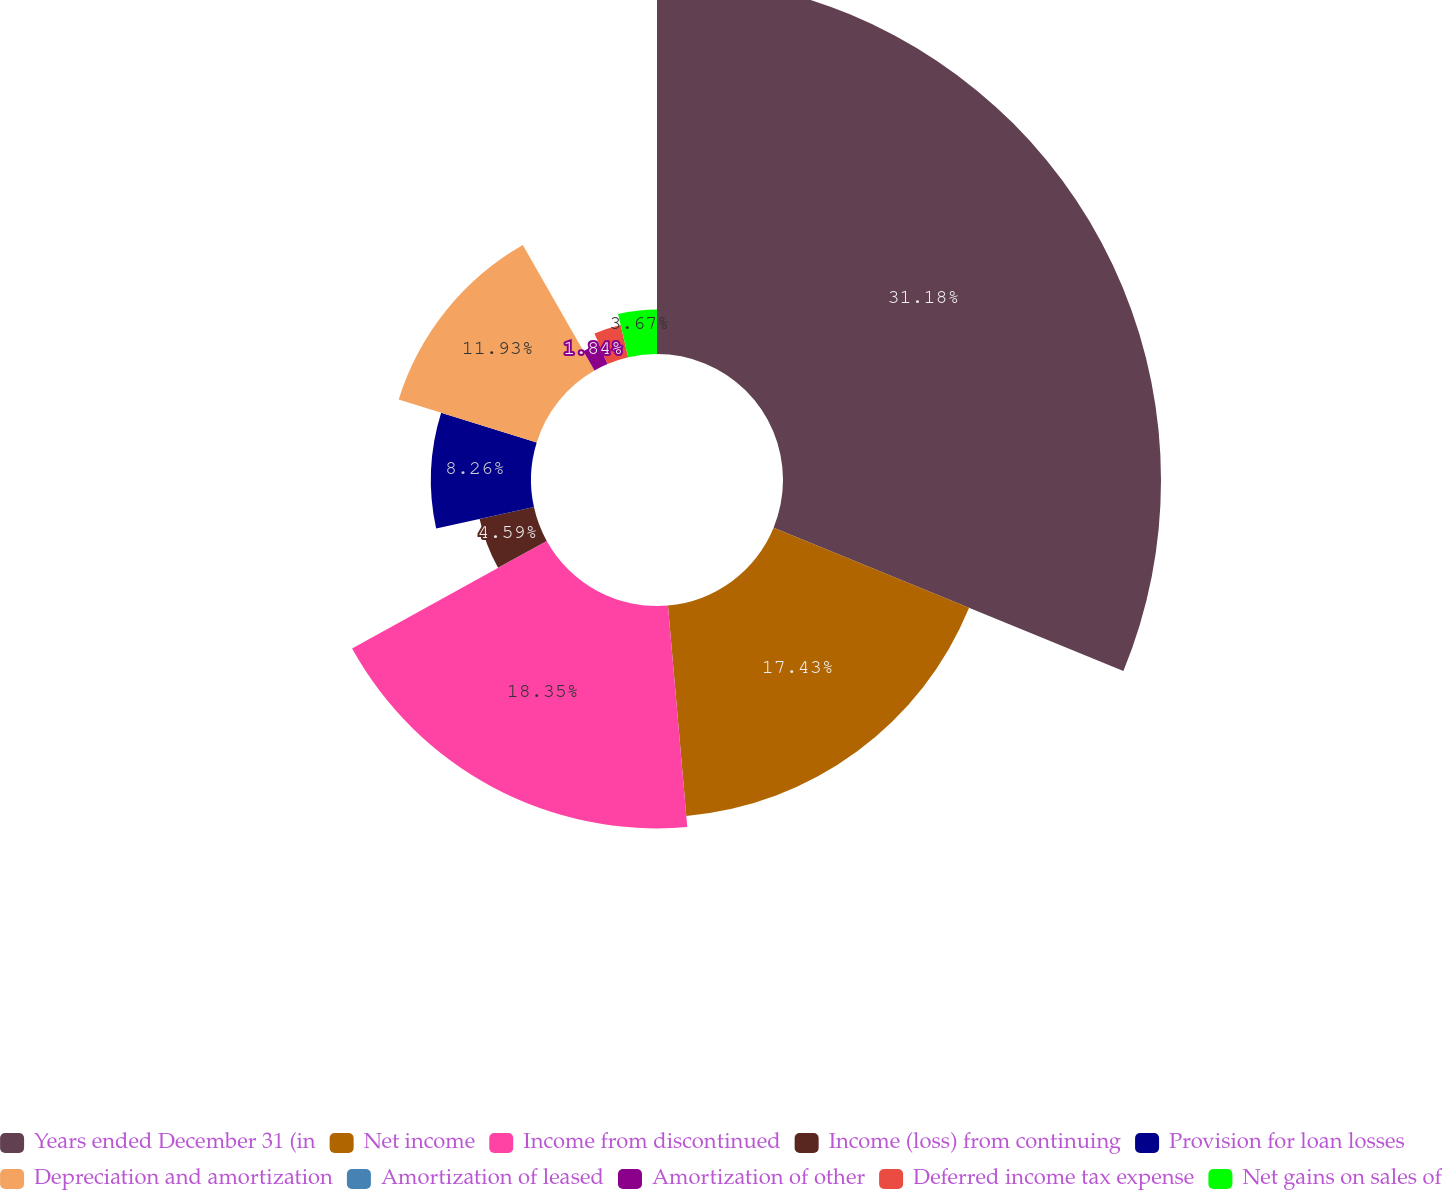Convert chart. <chart><loc_0><loc_0><loc_500><loc_500><pie_chart><fcel>Years ended December 31 (in<fcel>Net income<fcel>Income from discontinued<fcel>Income (loss) from continuing<fcel>Provision for loan losses<fcel>Depreciation and amortization<fcel>Amortization of leased<fcel>Amortization of other<fcel>Deferred income tax expense<fcel>Net gains on sales of<nl><fcel>31.19%<fcel>17.43%<fcel>18.35%<fcel>4.59%<fcel>8.26%<fcel>11.93%<fcel>0.0%<fcel>1.84%<fcel>2.75%<fcel>3.67%<nl></chart> 